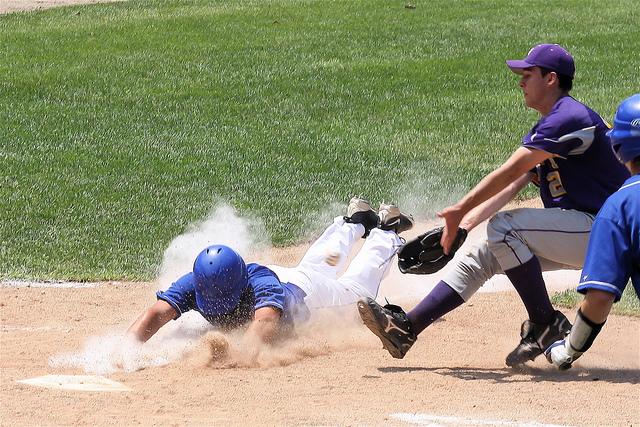How many players are on the ground?
Keep it brief. 1. Are the persons shown fighting?
Concise answer only. No. What technique is he demonstrating here?
Be succinct. Sliding. 